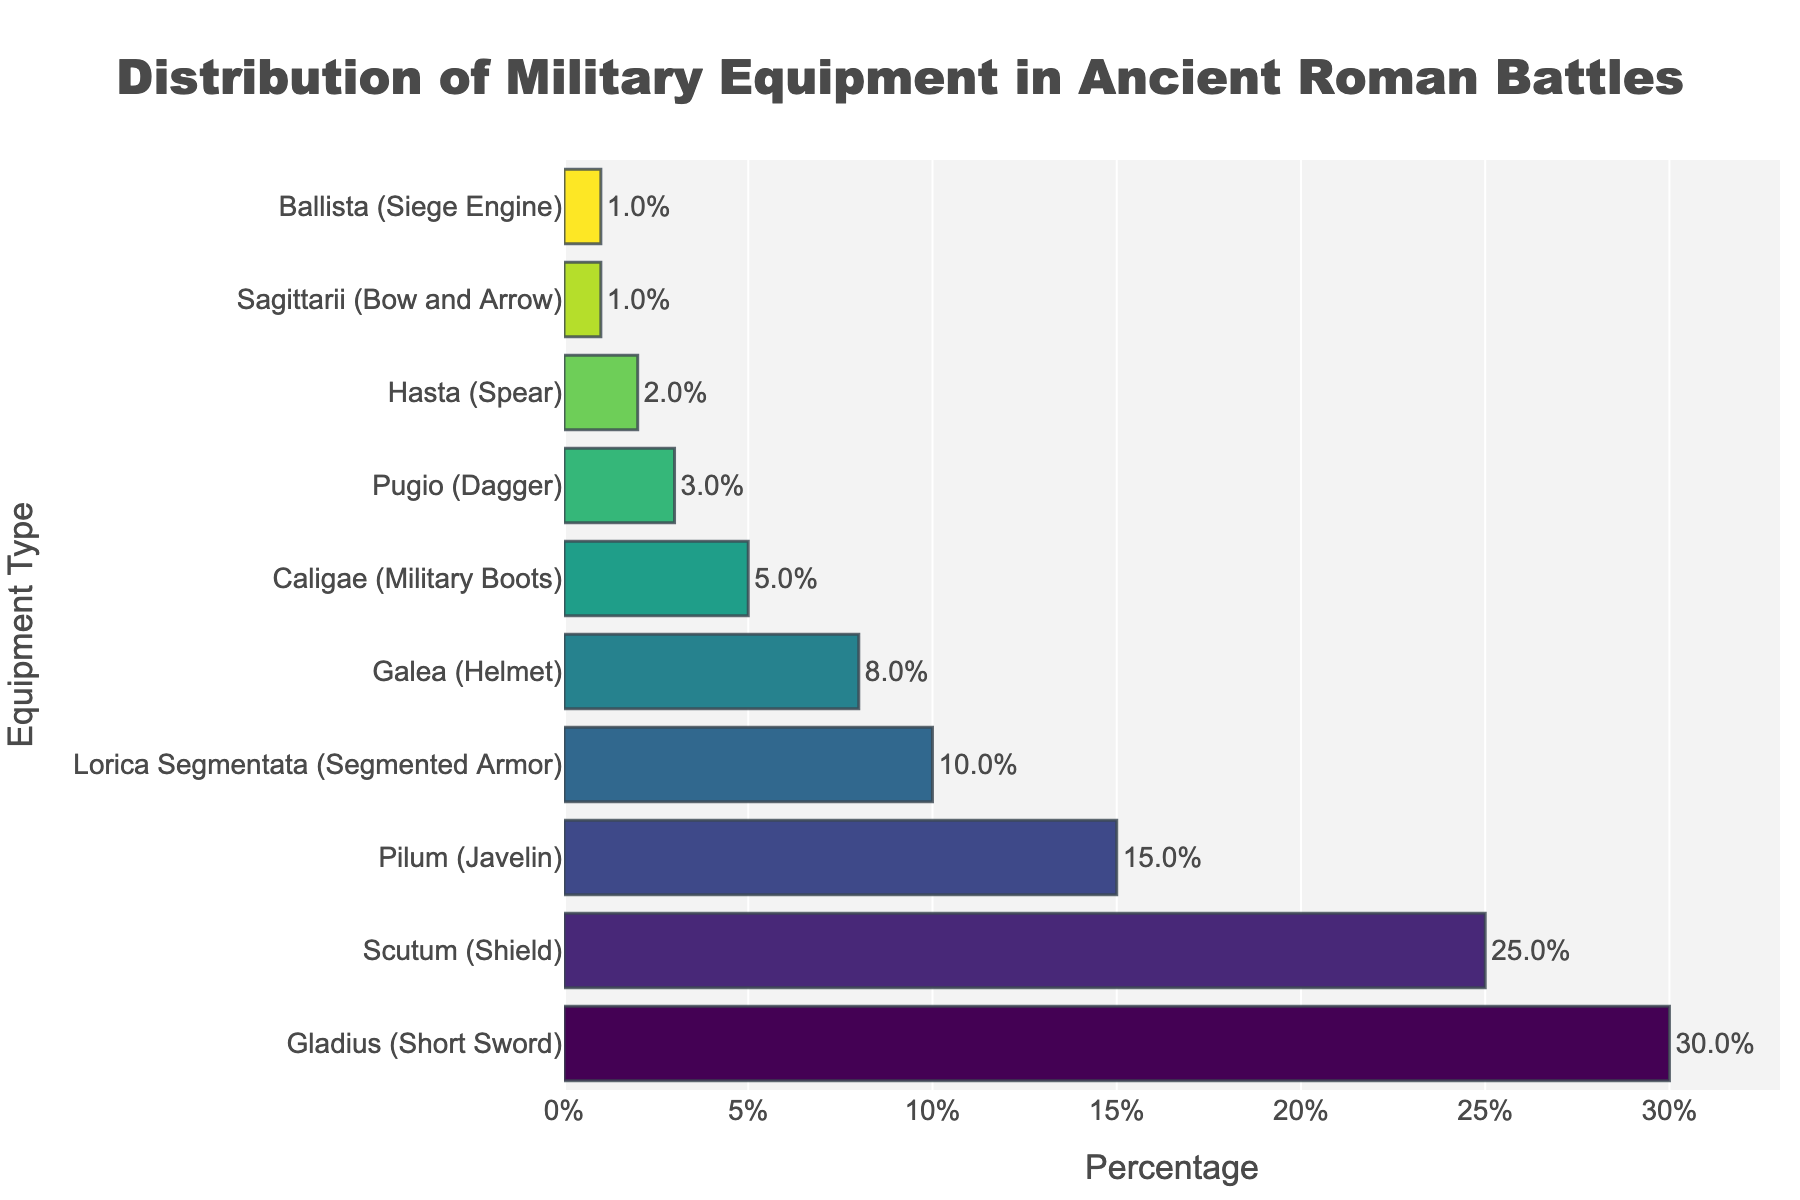What's the most common military equipment used in ancient Roman battles? The bar representing "Gladius (Short Sword)" is the longest, indicating it has the highest percentage among all equipment types.
Answer: Gladius (Short Sword) Which equipment type is used more, Pilum (Javelin) or Lorica Segmentata (Segmented Armor)? The bar representing "Pilum (Javelin)" is longer than that for "Lorica Segmentata (Segmented Armor)", indicating a higher percentage.
Answer: Pilum (Javelin) What is the total percentage of Scutum (Shield) and Galea (Helmet)? The percentage for Scutum (Shield) is 25% and for Galea (Helmet) is 8%. Summing them up: 25% + 8% = 33%.
Answer: 33% How many equipment types have a percentage higher than 10%? The equipment types with percentages higher than 10% are "Gladius (Short Sword)" at 30%, "Scutum (Shield)" at 25%, and "Pilum (Javelin)" at 15%. This makes it three types.
Answer: 3 What is the combined percentage for all equipment types less than 5%? The equipment types with percentages less than 5% are "Caligae (Military Boots)" at 5%, "Pugio (Dagger)" at 3%, "Hasta (Spear)" at 2%, "Sagittarii (Bow and Arrow)" at 1%, and "Ballista (Siege Engine)" at 1%. Summing them up: 5% + 3% + 2% + 1% + 1% = 12%.
Answer: 12% Which equipment type has the least usage, and what is its percentage? The shortest bars represent "Sagittarii (Bow and Arrow)" and "Ballista (Siege Engine)", each with a percentage of 1%.
Answer: Sagittarii (Bow and Arrow) and Ballista (Siege Engine), 1% Comparing Scutum (Shield) and Gladius (Short Sword), by what percentage does one exceed the other? Gladius (Short Sword) has a percentage of 30% and Scutum (Shield) has 25%. The difference is 30% - 25% = 5%.
Answer: 5% Which equipment follows the Galea (Helmet) in the distribution? The bar for "Galea (Helmet)" is followed by the bar for "Caligae (Military Boots)" in the sequence.
Answer: Caligae (Military Boots) What percentage of the total military equipment do Pilum (Javelin) and Lorica Segmentata (Segmented Armor) together constitute? The percentage for Pilum (Javelin) is 15% and for Lorica Segmentata (Segmented Armor) is 10%. Adding them together: 15% + 10% = 25%.
Answer: 25% 